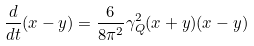<formula> <loc_0><loc_0><loc_500><loc_500>\frac { d } { d t } ( x - y ) = \frac { 6 } { 8 \pi ^ { 2 } } \gamma ^ { 2 } _ { Q } ( x + y ) ( x - y )</formula> 